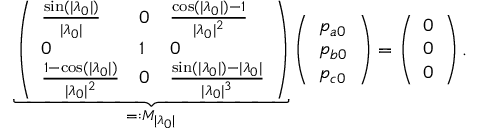<formula> <loc_0><loc_0><loc_500><loc_500>\underbrace { \left ( \begin{array} { l l l } { \frac { \sin ( | \lambda _ { 0 } | ) } { | \lambda _ { 0 } | } } & { 0 } & { \frac { \cos ( | \lambda _ { 0 } | ) - 1 } { | \lambda _ { 0 } | ^ { 2 } } } \\ { 0 } & { 1 } & { 0 } \\ { \frac { 1 - \cos ( | \lambda _ { 0 } | ) } { | \lambda _ { 0 } | ^ { 2 } } } & { 0 } & { \frac { \sin ( | \lambda _ { 0 } | ) - | \lambda _ { 0 } | } { | \lambda _ { 0 } | ^ { 3 } } } \end{array} \right ) } _ { = \colon M _ { | \lambda _ { 0 } | } } \left ( \begin{array} { l } { p _ { a 0 } } \\ { p _ { b 0 } } \\ { p _ { c 0 } } \end{array} \right ) = \left ( \begin{array} { l } { 0 } \\ { 0 } \\ { 0 } \end{array} \right ) .</formula> 